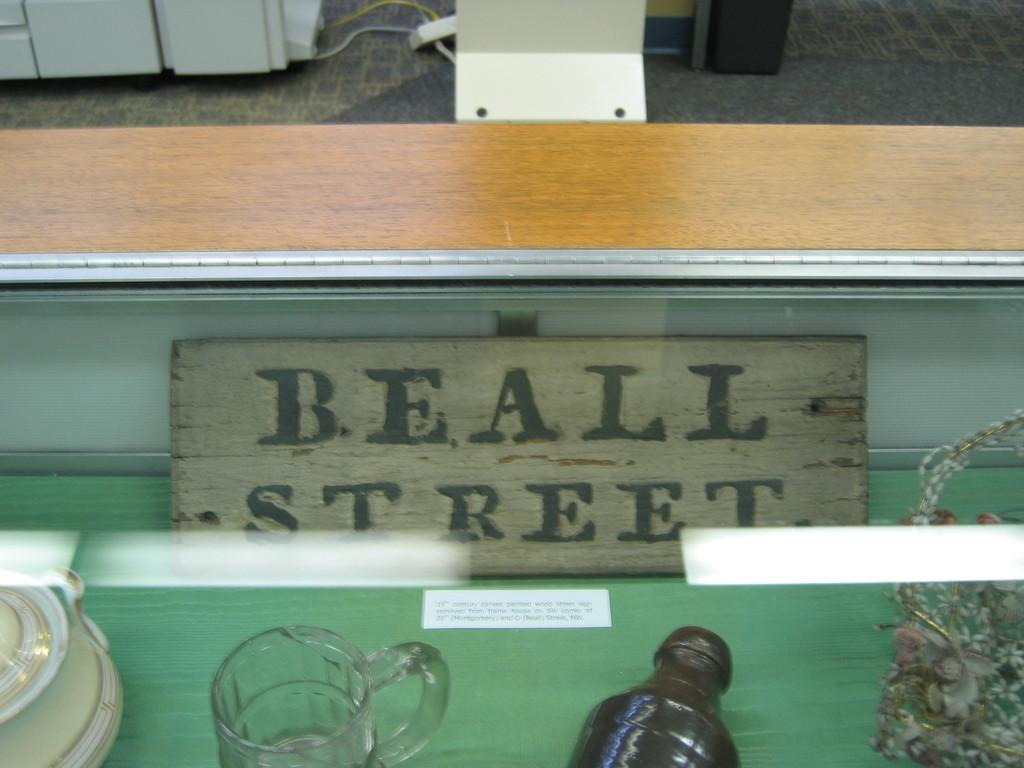<image>
Create a compact narrative representing the image presented. in the back of a display case is a sign that says BEALL STREET 